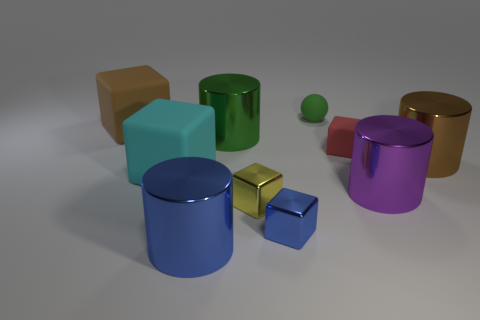There is a purple thing that is the same shape as the green metallic object; what size is it?
Make the answer very short. Large. Are there an equal number of things that are right of the large cyan matte cube and blue blocks?
Keep it short and to the point. No. There is a big brown object that is to the right of the green rubber sphere; is it the same shape as the cyan object?
Ensure brevity in your answer.  No. What is the shape of the tiny yellow thing?
Make the answer very short. Cube. There is a yellow thing that is in front of the tiny cube behind the brown thing that is right of the big cyan matte object; what is its material?
Make the answer very short. Metal. There is a object that is the same color as the small ball; what material is it?
Offer a very short reply. Metal. How many objects are either yellow cubes or large brown rubber cylinders?
Your answer should be very brief. 1. Does the green object that is on the left side of the tiny green ball have the same material as the tiny sphere?
Your response must be concise. No. What number of things are either metallic cylinders behind the small blue object or purple metallic balls?
Give a very brief answer. 3. What is the color of the small object that is the same material as the sphere?
Make the answer very short. Red. 